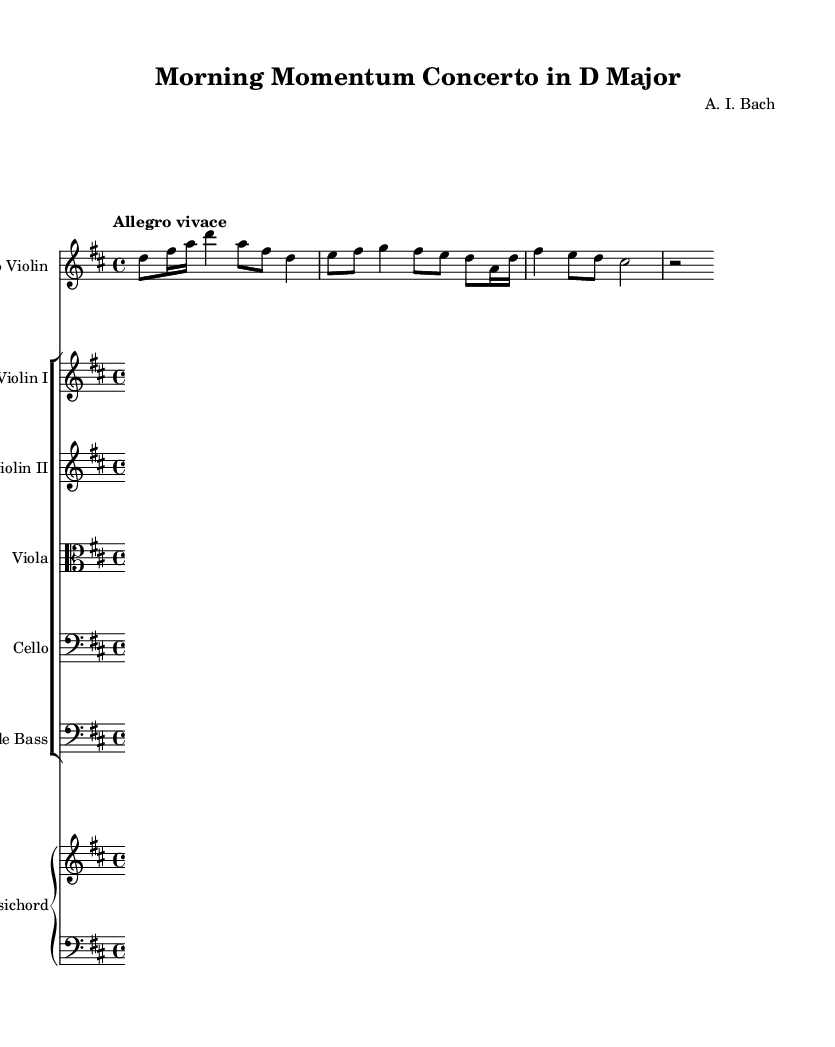What is the key signature of this music? The key signature is D major, which has two sharps (F# and C#). This can be determined by looking at the key signature indicated at the beginning of the staff.
Answer: D major What is the time signature of this concerto? The time signature is 4/4, which means there are four beats per measure, and each quarter note gets one beat. This is indicated at the start of the sheet music.
Answer: 4/4 What is the tempo marking of this piece? The tempo marking is "Allegro vivace," indicating a fast and lively pace. This is stated at the beginning of the music above the staff.
Answer: Allegro vivace How many instruments are played in this concerto? There are six types of instruments featured: solo violin, two violins, viola, cello, double bass, and harpsichord. This information can be found in the instrument list before the score.
Answer: Six Which instrument plays the solo part? The solo part is played by the violin, as indicated by the staff labeled "Solo Violin" at the beginning of the score.
Answer: Solo Violin What type of concerto is this based on its structure? This concerto is an energetic Baroque concerto, characterized by a lively tempo, expressive melodies, and interactions between the soloist and the ensemble. The use of a solo violin and accompaniment supports its classification within the Baroque genre.
Answer: Baroque concerto 